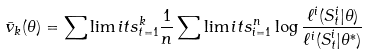<formula> <loc_0><loc_0><loc_500><loc_500>\bar { v } _ { k } ( \theta ) & = \sum \lim i t s _ { t = 1 } ^ { k } \frac { 1 } { n } \sum \lim i t s _ { i = 1 } ^ { n } \log \frac { \ell ^ { i } ( S _ { t } ^ { i } | \theta ) } { \ell ^ { i } ( S _ { t } ^ { i } | \theta ^ { * } ) }</formula> 